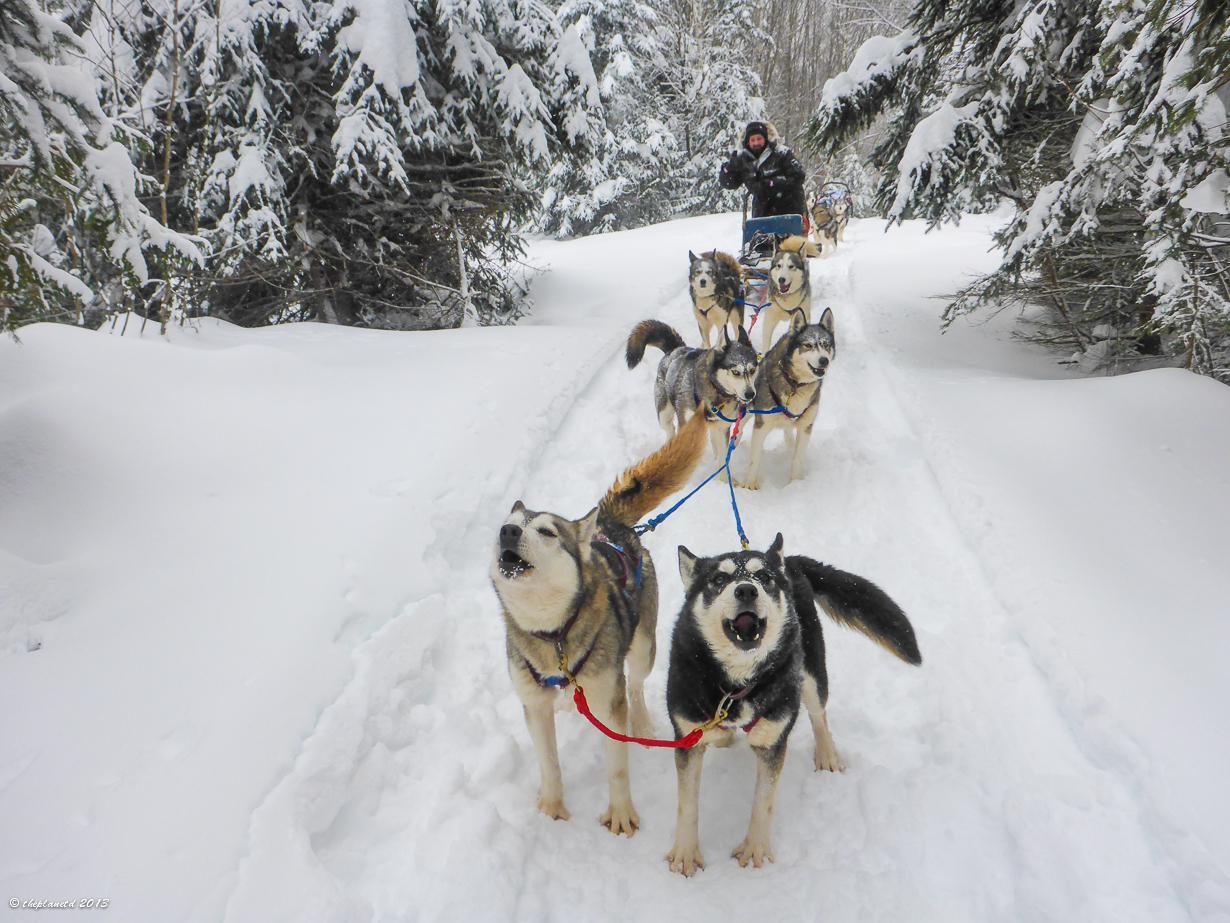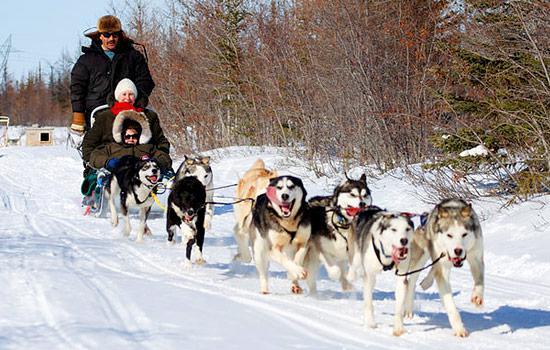The first image is the image on the left, the second image is the image on the right. Assess this claim about the two images: "There are no more than three sledding dogs in the right image.". Correct or not? Answer yes or no. No. 